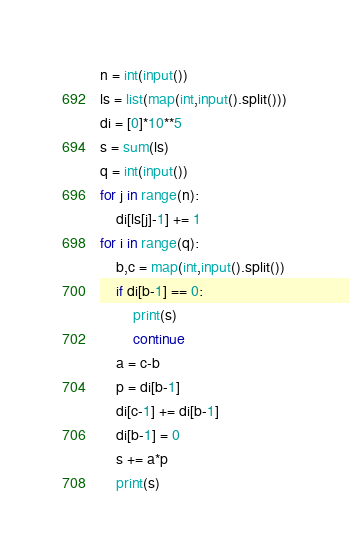Convert code to text. <code><loc_0><loc_0><loc_500><loc_500><_Python_>n = int(input())
ls = list(map(int,input().split()))
di = [0]*10**5
s = sum(ls)
q = int(input())
for j in range(n):
    di[ls[j]-1] += 1
for i in range(q):
    b,c = map(int,input().split())
    if di[b-1] == 0:
        print(s)
        continue
    a = c-b
    p = di[b-1]
    di[c-1] += di[b-1]
    di[b-1] = 0
    s += a*p
    print(s)</code> 